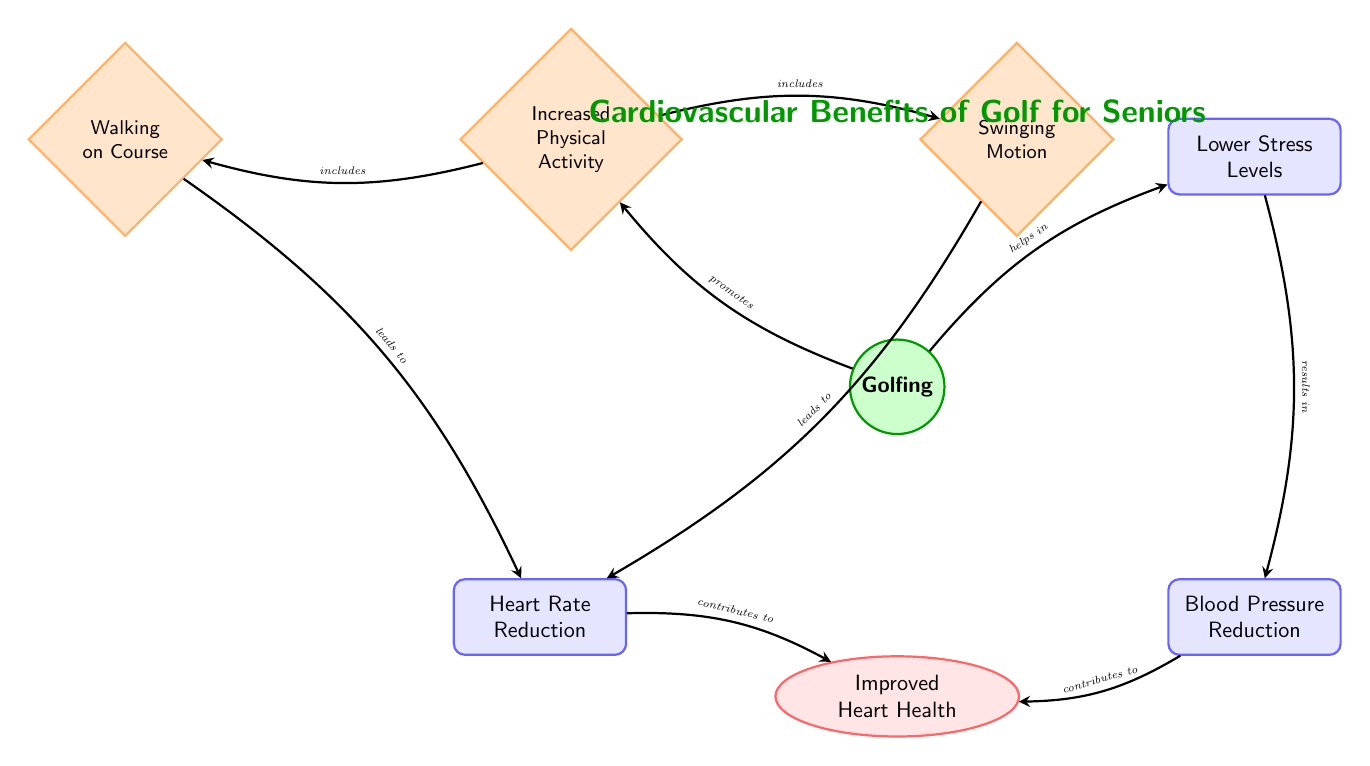What is the main activity depicted in the diagram? The node at the top of the diagram specifies "Golfing" as the central activity related to cardiovascular benefits.
Answer: Golfing How many effects are linked to golfing in the diagram? There are three effects linked to golfing: Heart Rate Reduction, Blood Pressure Reduction, and Lower Stress Levels.
Answer: 3 What two activities contribute to heart rate reduction in the context of golfing? The diagram shows "Walking on Course" and "Swinging Motion" as activities that lead to heart rate reduction.
Answer: Walking on Course, Swinging Motion Which effect results from lower stress levels according to the diagram? The arrow indicates that Lower Stress Levels lead to Blood Pressure Reduction, which is connected through a direct effect.
Answer: Blood Pressure Reduction What is the ultimate benefit of golfing as shown in the diagram? The diagram concludes with "Improved Heart Health" as the overall benefit resulting from the various effects associated with golfing activities.
Answer: Improved Heart Health How does increased physical activity relate to golfing? "Increased Physical Activity" is highlighted as an outcome of golfing, indicating that golfing promotes more physical engagement, leading to further health effects.
Answer: Promotes increased physical activity Which two nodes are effects resulting from golfing? The nodes showing effects resulting from golfing are "Heart Rate Reduction" and "Blood Pressure Reduction," both leading to improved health.
Answer: Heart Rate Reduction, Blood Pressure Reduction Which activity is mentioned as leading to heart rate reduction? The activities of "Walking on Course" and "Swinging Motion" are linked to causing a reduction in heart rate when engaging in golfing.
Answer: Walking on Course, Swinging Motion 